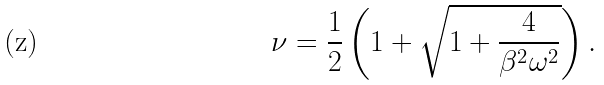Convert formula to latex. <formula><loc_0><loc_0><loc_500><loc_500>\nu = \frac { 1 } { 2 } \left ( 1 + \sqrt { 1 + \frac { 4 } { \beta ^ { 2 } \omega ^ { 2 } } } \right ) .</formula> 